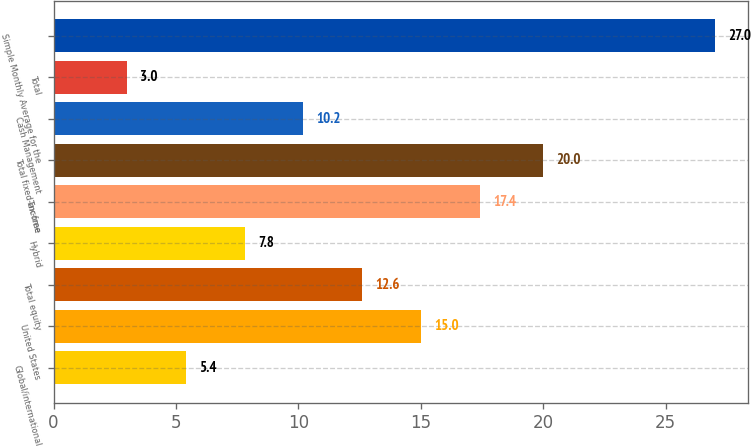Convert chart. <chart><loc_0><loc_0><loc_500><loc_500><bar_chart><fcel>Global/international<fcel>United States<fcel>Total equity<fcel>Hybrid<fcel>Tax-free<fcel>Total fixed-income<fcel>Cash Management<fcel>Total<fcel>Simple Monthly Average for the<nl><fcel>5.4<fcel>15<fcel>12.6<fcel>7.8<fcel>17.4<fcel>20<fcel>10.2<fcel>3<fcel>27<nl></chart> 